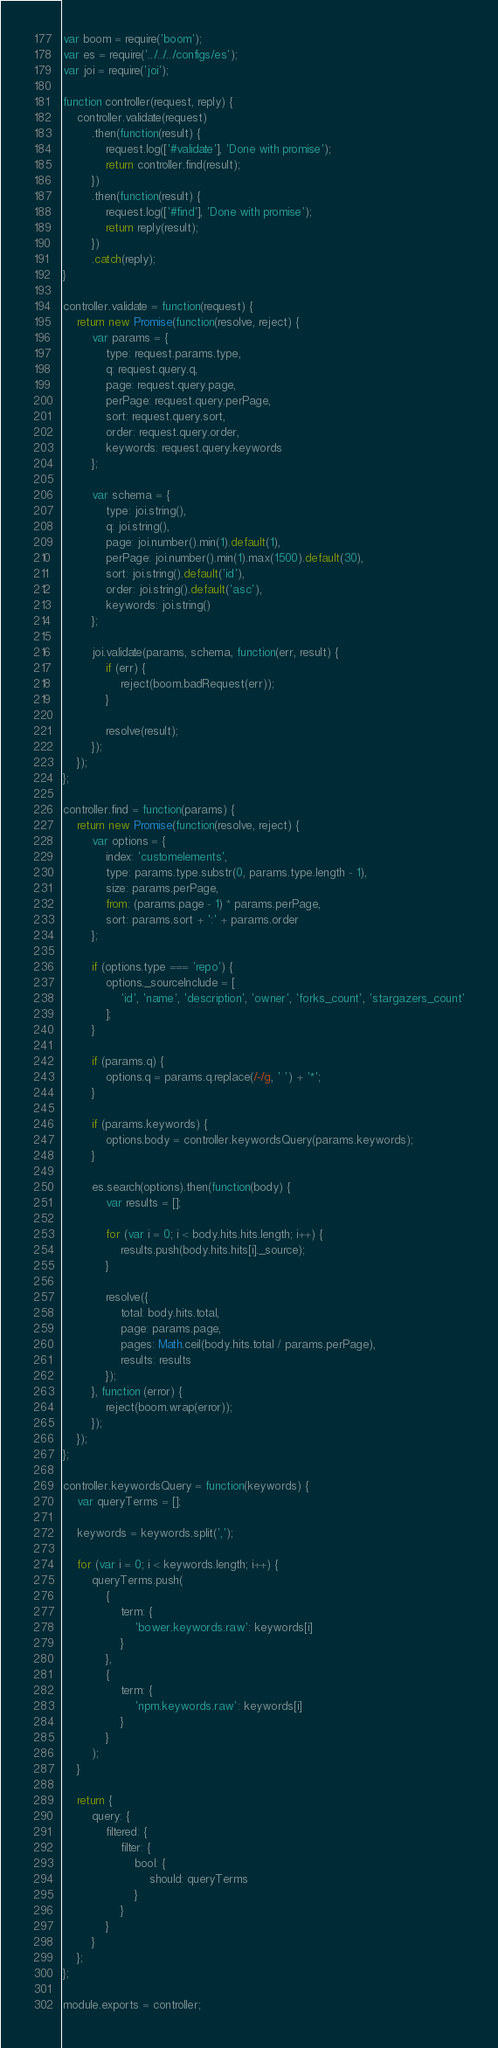<code> <loc_0><loc_0><loc_500><loc_500><_JavaScript_>var boom = require('boom');
var es = require('../../../configs/es');
var joi = require('joi');

function controller(request, reply) {
    controller.validate(request)
        .then(function(result) {
            request.log(['#validate'], 'Done with promise');
            return controller.find(result);
        })
        .then(function(result) {
            request.log(['#find'], 'Done with promise');
            return reply(result);
        })
        .catch(reply);
}

controller.validate = function(request) {
    return new Promise(function(resolve, reject) {
        var params = {
            type: request.params.type,
            q: request.query.q,
            page: request.query.page,
            perPage: request.query.perPage,
            sort: request.query.sort,
            order: request.query.order,
            keywords: request.query.keywords
        };

        var schema = {
            type: joi.string(),
            q: joi.string(),
            page: joi.number().min(1).default(1),
            perPage: joi.number().min(1).max(1500).default(30),
            sort: joi.string().default('id'),
            order: joi.string().default('asc'),
            keywords: joi.string()
        };

        joi.validate(params, schema, function(err, result) {
            if (err) {
                reject(boom.badRequest(err));
            }

            resolve(result);
        });
    });
};

controller.find = function(params) {
    return new Promise(function(resolve, reject) {
        var options = {
            index: 'customelements',
            type: params.type.substr(0, params.type.length - 1),
            size: params.perPage,
            from: (params.page - 1) * params.perPage,
            sort: params.sort + ':' + params.order
        };

        if (options.type === 'repo') {
            options._sourceInclude = [
                'id', 'name', 'description', 'owner', 'forks_count', 'stargazers_count'
            ];
        }

        if (params.q) {
            options.q = params.q.replace(/-/g, ' ') + '*';
        }

        if (params.keywords) {
            options.body = controller.keywordsQuery(params.keywords);
        }

        es.search(options).then(function(body) {
            var results = [];

            for (var i = 0; i < body.hits.hits.length; i++) {
                results.push(body.hits.hits[i]._source);
            }

            resolve({
                total: body.hits.total,
                page: params.page,
                pages: Math.ceil(body.hits.total / params.perPage),
                results: results
            });
        }, function (error) {
            reject(boom.wrap(error));
        });
    });
};

controller.keywordsQuery = function(keywords) {
    var queryTerms = [];

    keywords = keywords.split(',');

    for (var i = 0; i < keywords.length; i++) {
        queryTerms.push(
            {
                term: {
                    'bower.keywords.raw': keywords[i]
                }
            },
            {
                term: {
                    'npm.keywords.raw': keywords[i]
                }
            }
        );
    }

    return {
        query: {
            filtered: {
                filter: {
                    bool: {
                        should: queryTerms
                    }
                }
            }
        }
    };
};

module.exports = controller;
</code> 